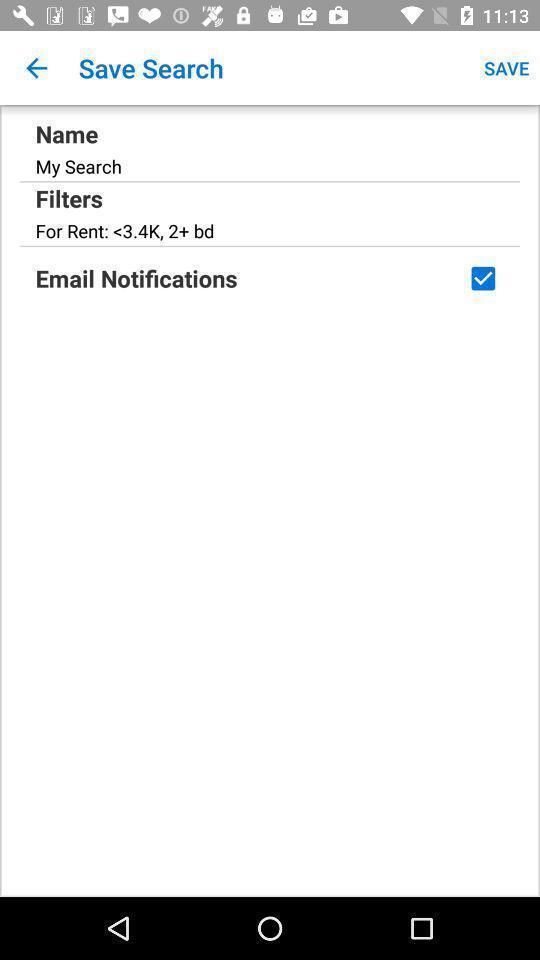Explain what's happening in this screen capture. Page displaying with search details. 